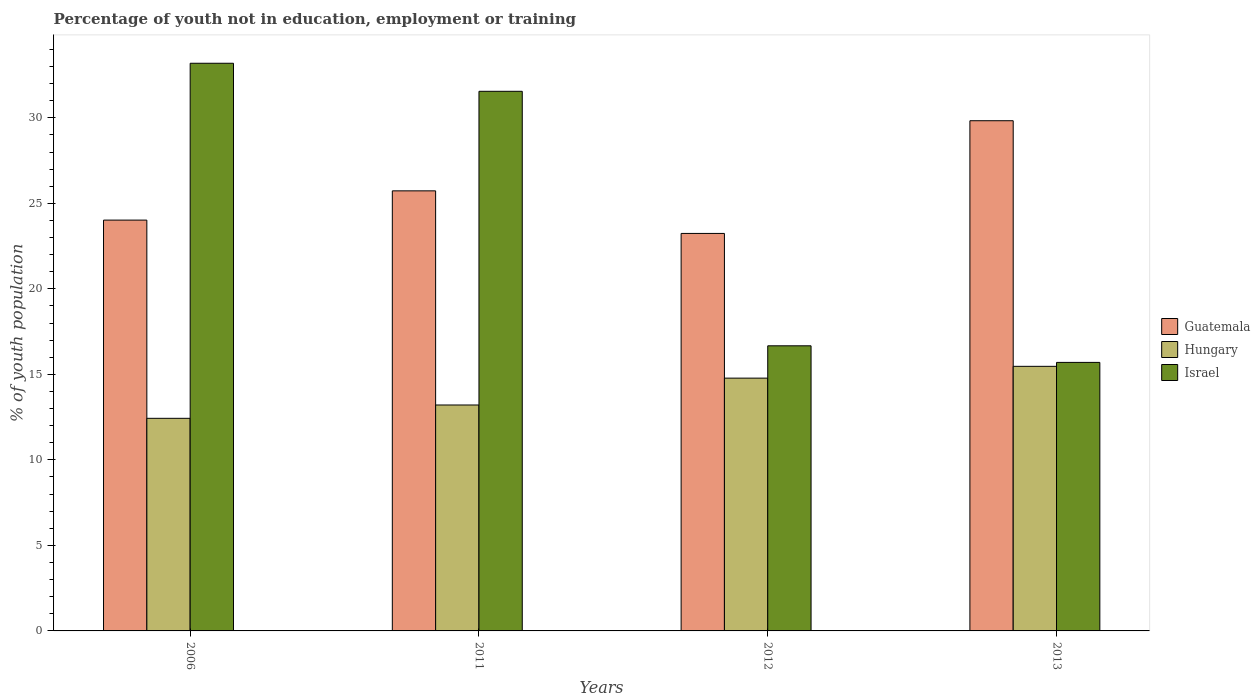How many different coloured bars are there?
Offer a very short reply. 3. How many groups of bars are there?
Offer a very short reply. 4. Are the number of bars per tick equal to the number of legend labels?
Your answer should be compact. Yes. Are the number of bars on each tick of the X-axis equal?
Provide a short and direct response. Yes. What is the label of the 3rd group of bars from the left?
Your answer should be compact. 2012. What is the percentage of unemployed youth population in in Guatemala in 2006?
Provide a short and direct response. 24.02. Across all years, what is the maximum percentage of unemployed youth population in in Guatemala?
Make the answer very short. 29.83. Across all years, what is the minimum percentage of unemployed youth population in in Israel?
Your answer should be compact. 15.7. In which year was the percentage of unemployed youth population in in Hungary maximum?
Make the answer very short. 2013. In which year was the percentage of unemployed youth population in in Hungary minimum?
Your response must be concise. 2006. What is the total percentage of unemployed youth population in in Guatemala in the graph?
Your answer should be very brief. 102.82. What is the difference between the percentage of unemployed youth population in in Guatemala in 2011 and that in 2012?
Your answer should be very brief. 2.49. What is the difference between the percentage of unemployed youth population in in Guatemala in 2011 and the percentage of unemployed youth population in in Israel in 2012?
Ensure brevity in your answer.  9.06. What is the average percentage of unemployed youth population in in Israel per year?
Offer a terse response. 24.28. In the year 2013, what is the difference between the percentage of unemployed youth population in in Israel and percentage of unemployed youth population in in Guatemala?
Your answer should be compact. -14.13. What is the ratio of the percentage of unemployed youth population in in Hungary in 2011 to that in 2013?
Keep it short and to the point. 0.85. What is the difference between the highest and the second highest percentage of unemployed youth population in in Israel?
Your answer should be compact. 1.64. What is the difference between the highest and the lowest percentage of unemployed youth population in in Hungary?
Provide a short and direct response. 3.04. In how many years, is the percentage of unemployed youth population in in Guatemala greater than the average percentage of unemployed youth population in in Guatemala taken over all years?
Your answer should be very brief. 2. What does the 1st bar from the left in 2013 represents?
Ensure brevity in your answer.  Guatemala. What does the 3rd bar from the right in 2006 represents?
Ensure brevity in your answer.  Guatemala. Are all the bars in the graph horizontal?
Offer a terse response. No. How many years are there in the graph?
Offer a very short reply. 4. How many legend labels are there?
Offer a very short reply. 3. How are the legend labels stacked?
Provide a short and direct response. Vertical. What is the title of the graph?
Make the answer very short. Percentage of youth not in education, employment or training. What is the label or title of the Y-axis?
Make the answer very short. % of youth population. What is the % of youth population of Guatemala in 2006?
Ensure brevity in your answer.  24.02. What is the % of youth population of Hungary in 2006?
Give a very brief answer. 12.43. What is the % of youth population in Israel in 2006?
Make the answer very short. 33.19. What is the % of youth population in Guatemala in 2011?
Give a very brief answer. 25.73. What is the % of youth population in Hungary in 2011?
Your response must be concise. 13.21. What is the % of youth population in Israel in 2011?
Ensure brevity in your answer.  31.55. What is the % of youth population of Guatemala in 2012?
Ensure brevity in your answer.  23.24. What is the % of youth population in Hungary in 2012?
Keep it short and to the point. 14.78. What is the % of youth population in Israel in 2012?
Your response must be concise. 16.67. What is the % of youth population of Guatemala in 2013?
Your answer should be very brief. 29.83. What is the % of youth population of Hungary in 2013?
Your answer should be very brief. 15.47. What is the % of youth population of Israel in 2013?
Your response must be concise. 15.7. Across all years, what is the maximum % of youth population in Guatemala?
Provide a succinct answer. 29.83. Across all years, what is the maximum % of youth population in Hungary?
Your answer should be very brief. 15.47. Across all years, what is the maximum % of youth population of Israel?
Give a very brief answer. 33.19. Across all years, what is the minimum % of youth population in Guatemala?
Provide a succinct answer. 23.24. Across all years, what is the minimum % of youth population in Hungary?
Provide a succinct answer. 12.43. Across all years, what is the minimum % of youth population in Israel?
Offer a very short reply. 15.7. What is the total % of youth population in Guatemala in the graph?
Your response must be concise. 102.82. What is the total % of youth population in Hungary in the graph?
Ensure brevity in your answer.  55.89. What is the total % of youth population in Israel in the graph?
Your response must be concise. 97.11. What is the difference between the % of youth population of Guatemala in 2006 and that in 2011?
Your answer should be compact. -1.71. What is the difference between the % of youth population in Hungary in 2006 and that in 2011?
Your answer should be very brief. -0.78. What is the difference between the % of youth population in Israel in 2006 and that in 2011?
Ensure brevity in your answer.  1.64. What is the difference between the % of youth population in Guatemala in 2006 and that in 2012?
Your response must be concise. 0.78. What is the difference between the % of youth population of Hungary in 2006 and that in 2012?
Provide a succinct answer. -2.35. What is the difference between the % of youth population of Israel in 2006 and that in 2012?
Give a very brief answer. 16.52. What is the difference between the % of youth population in Guatemala in 2006 and that in 2013?
Ensure brevity in your answer.  -5.81. What is the difference between the % of youth population in Hungary in 2006 and that in 2013?
Offer a very short reply. -3.04. What is the difference between the % of youth population of Israel in 2006 and that in 2013?
Offer a terse response. 17.49. What is the difference between the % of youth population of Guatemala in 2011 and that in 2012?
Make the answer very short. 2.49. What is the difference between the % of youth population in Hungary in 2011 and that in 2012?
Provide a succinct answer. -1.57. What is the difference between the % of youth population of Israel in 2011 and that in 2012?
Provide a short and direct response. 14.88. What is the difference between the % of youth population of Guatemala in 2011 and that in 2013?
Offer a very short reply. -4.1. What is the difference between the % of youth population of Hungary in 2011 and that in 2013?
Your answer should be compact. -2.26. What is the difference between the % of youth population in Israel in 2011 and that in 2013?
Keep it short and to the point. 15.85. What is the difference between the % of youth population in Guatemala in 2012 and that in 2013?
Provide a short and direct response. -6.59. What is the difference between the % of youth population in Hungary in 2012 and that in 2013?
Provide a short and direct response. -0.69. What is the difference between the % of youth population of Israel in 2012 and that in 2013?
Make the answer very short. 0.97. What is the difference between the % of youth population in Guatemala in 2006 and the % of youth population in Hungary in 2011?
Offer a terse response. 10.81. What is the difference between the % of youth population in Guatemala in 2006 and the % of youth population in Israel in 2011?
Make the answer very short. -7.53. What is the difference between the % of youth population in Hungary in 2006 and the % of youth population in Israel in 2011?
Provide a short and direct response. -19.12. What is the difference between the % of youth population of Guatemala in 2006 and the % of youth population of Hungary in 2012?
Ensure brevity in your answer.  9.24. What is the difference between the % of youth population in Guatemala in 2006 and the % of youth population in Israel in 2012?
Offer a terse response. 7.35. What is the difference between the % of youth population in Hungary in 2006 and the % of youth population in Israel in 2012?
Make the answer very short. -4.24. What is the difference between the % of youth population in Guatemala in 2006 and the % of youth population in Hungary in 2013?
Your answer should be compact. 8.55. What is the difference between the % of youth population of Guatemala in 2006 and the % of youth population of Israel in 2013?
Your answer should be very brief. 8.32. What is the difference between the % of youth population of Hungary in 2006 and the % of youth population of Israel in 2013?
Your response must be concise. -3.27. What is the difference between the % of youth population in Guatemala in 2011 and the % of youth population in Hungary in 2012?
Offer a very short reply. 10.95. What is the difference between the % of youth population in Guatemala in 2011 and the % of youth population in Israel in 2012?
Provide a short and direct response. 9.06. What is the difference between the % of youth population of Hungary in 2011 and the % of youth population of Israel in 2012?
Ensure brevity in your answer.  -3.46. What is the difference between the % of youth population in Guatemala in 2011 and the % of youth population in Hungary in 2013?
Your answer should be compact. 10.26. What is the difference between the % of youth population of Guatemala in 2011 and the % of youth population of Israel in 2013?
Offer a terse response. 10.03. What is the difference between the % of youth population of Hungary in 2011 and the % of youth population of Israel in 2013?
Provide a short and direct response. -2.49. What is the difference between the % of youth population in Guatemala in 2012 and the % of youth population in Hungary in 2013?
Give a very brief answer. 7.77. What is the difference between the % of youth population in Guatemala in 2012 and the % of youth population in Israel in 2013?
Provide a succinct answer. 7.54. What is the difference between the % of youth population of Hungary in 2012 and the % of youth population of Israel in 2013?
Ensure brevity in your answer.  -0.92. What is the average % of youth population in Guatemala per year?
Ensure brevity in your answer.  25.7. What is the average % of youth population in Hungary per year?
Provide a succinct answer. 13.97. What is the average % of youth population of Israel per year?
Provide a succinct answer. 24.28. In the year 2006, what is the difference between the % of youth population in Guatemala and % of youth population in Hungary?
Keep it short and to the point. 11.59. In the year 2006, what is the difference between the % of youth population of Guatemala and % of youth population of Israel?
Give a very brief answer. -9.17. In the year 2006, what is the difference between the % of youth population of Hungary and % of youth population of Israel?
Provide a succinct answer. -20.76. In the year 2011, what is the difference between the % of youth population in Guatemala and % of youth population in Hungary?
Give a very brief answer. 12.52. In the year 2011, what is the difference between the % of youth population of Guatemala and % of youth population of Israel?
Give a very brief answer. -5.82. In the year 2011, what is the difference between the % of youth population of Hungary and % of youth population of Israel?
Your answer should be compact. -18.34. In the year 2012, what is the difference between the % of youth population in Guatemala and % of youth population in Hungary?
Offer a very short reply. 8.46. In the year 2012, what is the difference between the % of youth population of Guatemala and % of youth population of Israel?
Make the answer very short. 6.57. In the year 2012, what is the difference between the % of youth population of Hungary and % of youth population of Israel?
Provide a short and direct response. -1.89. In the year 2013, what is the difference between the % of youth population of Guatemala and % of youth population of Hungary?
Offer a very short reply. 14.36. In the year 2013, what is the difference between the % of youth population of Guatemala and % of youth population of Israel?
Offer a very short reply. 14.13. In the year 2013, what is the difference between the % of youth population of Hungary and % of youth population of Israel?
Offer a terse response. -0.23. What is the ratio of the % of youth population of Guatemala in 2006 to that in 2011?
Offer a very short reply. 0.93. What is the ratio of the % of youth population of Hungary in 2006 to that in 2011?
Offer a very short reply. 0.94. What is the ratio of the % of youth population in Israel in 2006 to that in 2011?
Offer a terse response. 1.05. What is the ratio of the % of youth population in Guatemala in 2006 to that in 2012?
Keep it short and to the point. 1.03. What is the ratio of the % of youth population in Hungary in 2006 to that in 2012?
Ensure brevity in your answer.  0.84. What is the ratio of the % of youth population in Israel in 2006 to that in 2012?
Your answer should be compact. 1.99. What is the ratio of the % of youth population in Guatemala in 2006 to that in 2013?
Ensure brevity in your answer.  0.81. What is the ratio of the % of youth population in Hungary in 2006 to that in 2013?
Your response must be concise. 0.8. What is the ratio of the % of youth population in Israel in 2006 to that in 2013?
Keep it short and to the point. 2.11. What is the ratio of the % of youth population in Guatemala in 2011 to that in 2012?
Your answer should be very brief. 1.11. What is the ratio of the % of youth population in Hungary in 2011 to that in 2012?
Make the answer very short. 0.89. What is the ratio of the % of youth population of Israel in 2011 to that in 2012?
Ensure brevity in your answer.  1.89. What is the ratio of the % of youth population in Guatemala in 2011 to that in 2013?
Keep it short and to the point. 0.86. What is the ratio of the % of youth population in Hungary in 2011 to that in 2013?
Provide a succinct answer. 0.85. What is the ratio of the % of youth population in Israel in 2011 to that in 2013?
Keep it short and to the point. 2.01. What is the ratio of the % of youth population of Guatemala in 2012 to that in 2013?
Make the answer very short. 0.78. What is the ratio of the % of youth population in Hungary in 2012 to that in 2013?
Your answer should be compact. 0.96. What is the ratio of the % of youth population of Israel in 2012 to that in 2013?
Your answer should be very brief. 1.06. What is the difference between the highest and the second highest % of youth population of Guatemala?
Your response must be concise. 4.1. What is the difference between the highest and the second highest % of youth population in Hungary?
Provide a short and direct response. 0.69. What is the difference between the highest and the second highest % of youth population in Israel?
Offer a terse response. 1.64. What is the difference between the highest and the lowest % of youth population of Guatemala?
Your answer should be very brief. 6.59. What is the difference between the highest and the lowest % of youth population of Hungary?
Provide a succinct answer. 3.04. What is the difference between the highest and the lowest % of youth population of Israel?
Give a very brief answer. 17.49. 